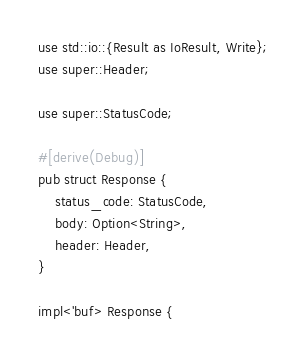<code> <loc_0><loc_0><loc_500><loc_500><_Rust_>use std::io::{Result as IoResult, Write};
use super::Header;

use super::StatusCode;

#[derive(Debug)]
pub struct Response {
    status_code: StatusCode,
    body: Option<String>,
    header: Header,
}

impl<'buf> Response {</code> 